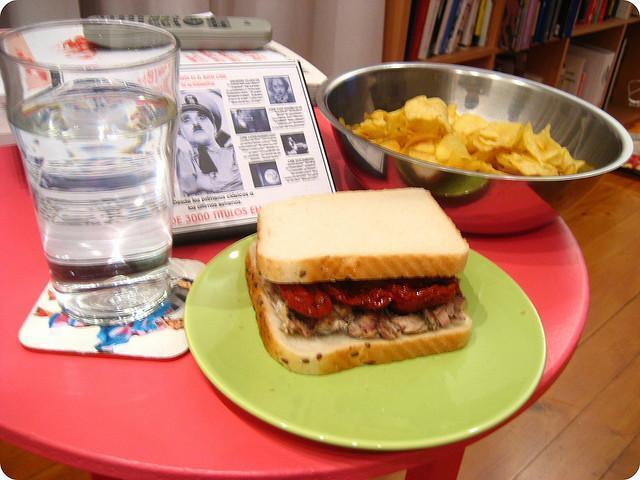Is the caption "The sandwich is in front of the bowl." a true representation of the image?
Answer yes or no. Yes. 